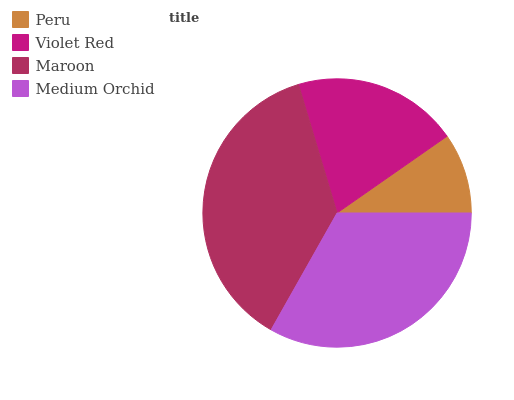Is Peru the minimum?
Answer yes or no. Yes. Is Maroon the maximum?
Answer yes or no. Yes. Is Violet Red the minimum?
Answer yes or no. No. Is Violet Red the maximum?
Answer yes or no. No. Is Violet Red greater than Peru?
Answer yes or no. Yes. Is Peru less than Violet Red?
Answer yes or no. Yes. Is Peru greater than Violet Red?
Answer yes or no. No. Is Violet Red less than Peru?
Answer yes or no. No. Is Medium Orchid the high median?
Answer yes or no. Yes. Is Violet Red the low median?
Answer yes or no. Yes. Is Violet Red the high median?
Answer yes or no. No. Is Medium Orchid the low median?
Answer yes or no. No. 